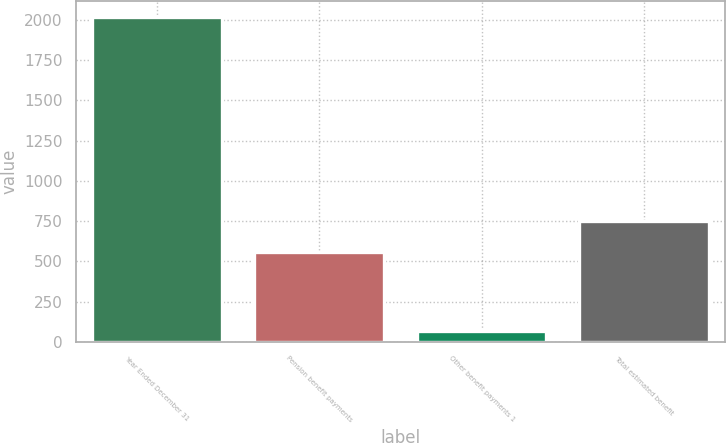Convert chart to OTSL. <chart><loc_0><loc_0><loc_500><loc_500><bar_chart><fcel>Year Ended December 31<fcel>Pension benefit payments<fcel>Other benefit payments 1<fcel>Total estimated benefit<nl><fcel>2018<fcel>558<fcel>66<fcel>753.2<nl></chart> 